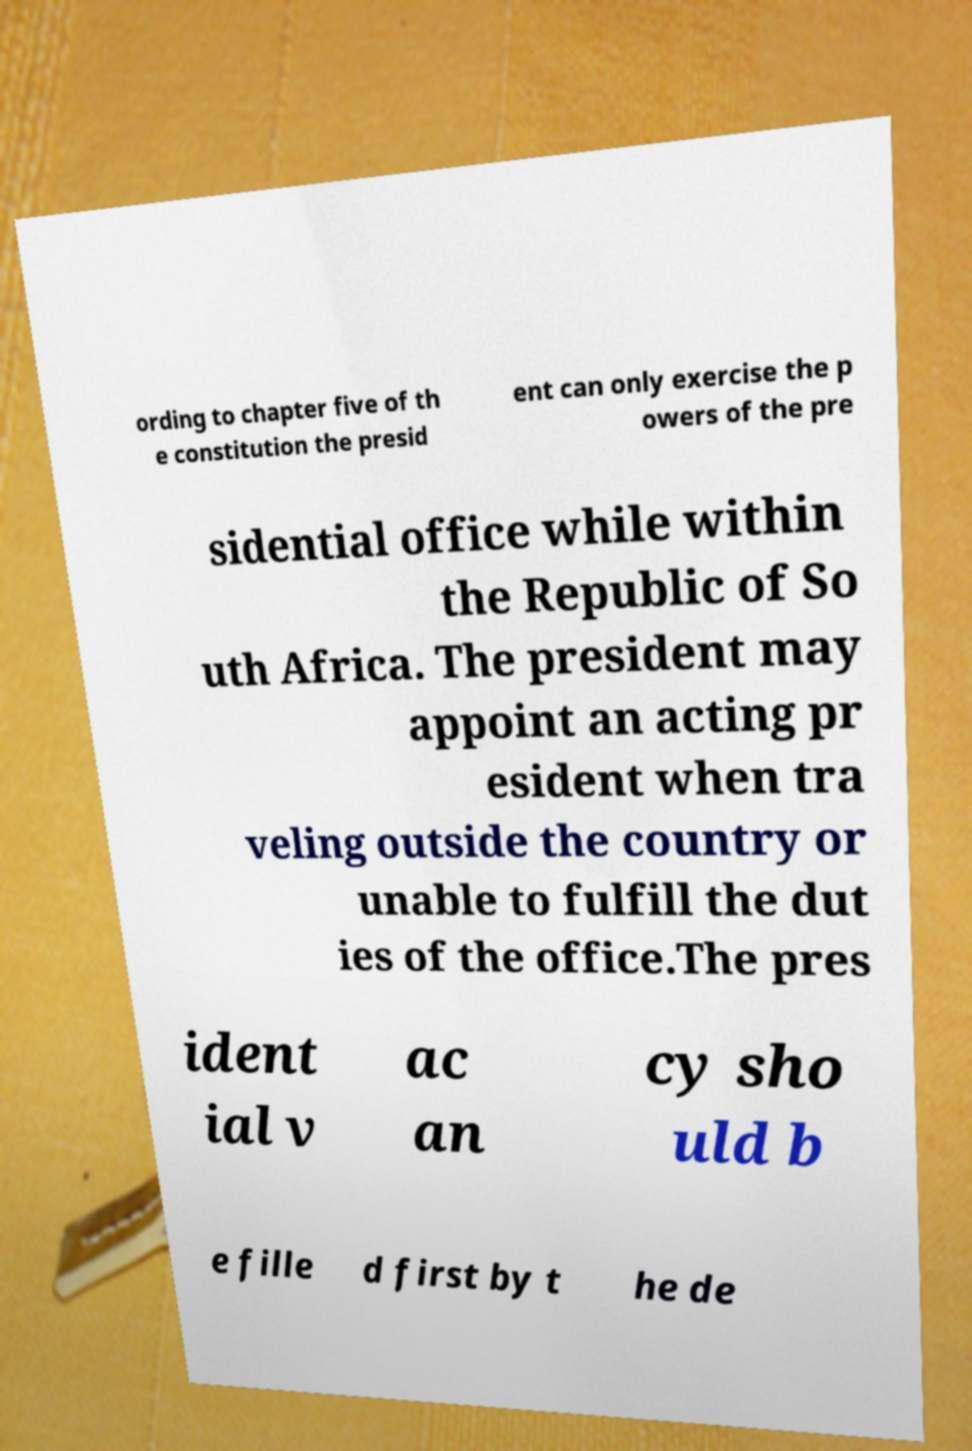For documentation purposes, I need the text within this image transcribed. Could you provide that? ording to chapter five of th e constitution the presid ent can only exercise the p owers of the pre sidential office while within the Republic of So uth Africa. The president may appoint an acting pr esident when tra veling outside the country or unable to fulfill the dut ies of the office.The pres ident ial v ac an cy sho uld b e fille d first by t he de 